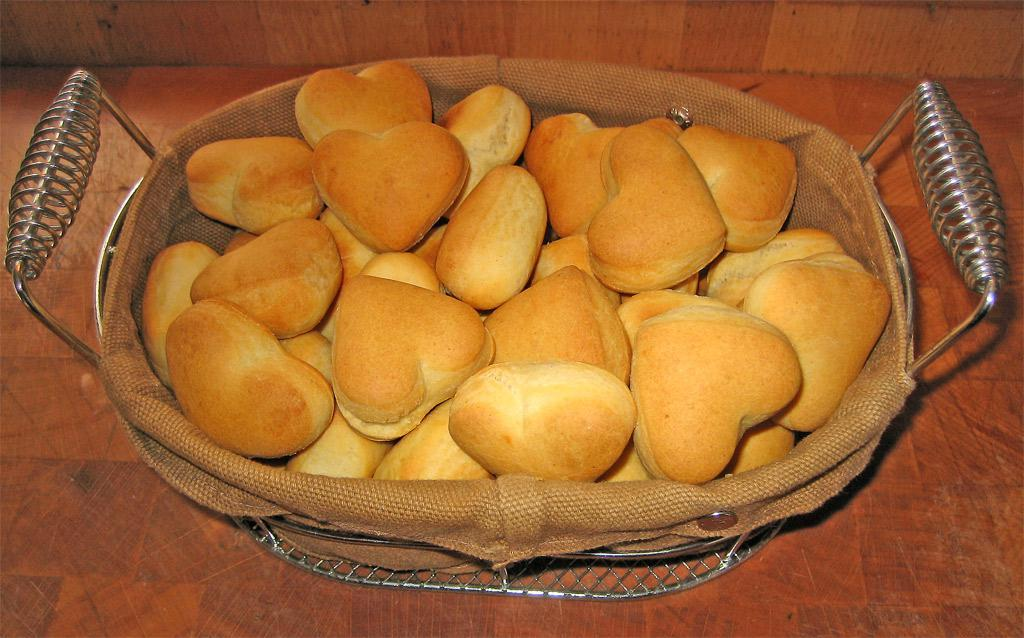Where was the image taken? The image was taken indoors. What piece of furniture is present in the image? There is a table in the image. What is placed on the table? There is a basket on the table. What is inside the basket? The basket contains many cookies. What might be used for cleaning or wiping in the image? There is a napkin on the table for cleaning or wiping. Are there any ants crawling on the cookies in the image? There is no indication of ants or any other insects in the image. What type of wrench is used to open the basket in the image? There is: There is no wrench present in the image, and the basket does not require a wrench to open it. 